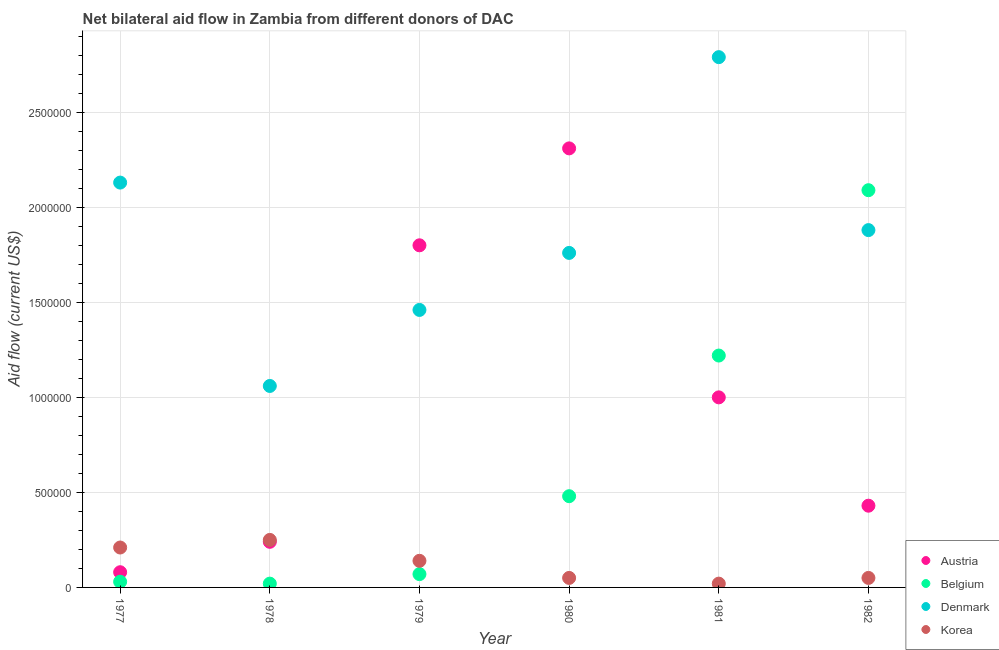Is the number of dotlines equal to the number of legend labels?
Your answer should be very brief. Yes. What is the amount of aid given by korea in 1978?
Give a very brief answer. 2.50e+05. Across all years, what is the maximum amount of aid given by belgium?
Provide a short and direct response. 2.09e+06. Across all years, what is the minimum amount of aid given by korea?
Give a very brief answer. 2.00e+04. In which year was the amount of aid given by austria maximum?
Your answer should be very brief. 1980. In which year was the amount of aid given by belgium minimum?
Provide a short and direct response. 1978. What is the total amount of aid given by belgium in the graph?
Offer a very short reply. 3.91e+06. What is the difference between the amount of aid given by denmark in 1978 and that in 1979?
Offer a very short reply. -4.00e+05. What is the difference between the amount of aid given by denmark in 1981 and the amount of aid given by austria in 1977?
Make the answer very short. 2.71e+06. What is the average amount of aid given by austria per year?
Your response must be concise. 9.77e+05. In the year 1978, what is the difference between the amount of aid given by austria and amount of aid given by belgium?
Your answer should be very brief. 2.20e+05. What is the ratio of the amount of aid given by denmark in 1977 to that in 1981?
Your answer should be very brief. 0.76. What is the difference between the highest and the second highest amount of aid given by austria?
Offer a terse response. 5.10e+05. What is the difference between the highest and the lowest amount of aid given by austria?
Keep it short and to the point. 2.23e+06. In how many years, is the amount of aid given by denmark greater than the average amount of aid given by denmark taken over all years?
Your response must be concise. 3. Is the sum of the amount of aid given by denmark in 1978 and 1981 greater than the maximum amount of aid given by korea across all years?
Offer a terse response. Yes. How many years are there in the graph?
Give a very brief answer. 6. What is the difference between two consecutive major ticks on the Y-axis?
Your answer should be compact. 5.00e+05. Does the graph contain any zero values?
Make the answer very short. No. Where does the legend appear in the graph?
Offer a terse response. Bottom right. How are the legend labels stacked?
Your answer should be compact. Vertical. What is the title of the graph?
Your answer should be very brief. Net bilateral aid flow in Zambia from different donors of DAC. What is the Aid flow (current US$) in Austria in 1977?
Provide a succinct answer. 8.00e+04. What is the Aid flow (current US$) in Belgium in 1977?
Keep it short and to the point. 3.00e+04. What is the Aid flow (current US$) of Denmark in 1977?
Your answer should be compact. 2.13e+06. What is the Aid flow (current US$) of Belgium in 1978?
Provide a short and direct response. 2.00e+04. What is the Aid flow (current US$) in Denmark in 1978?
Your answer should be very brief. 1.06e+06. What is the Aid flow (current US$) of Austria in 1979?
Offer a very short reply. 1.80e+06. What is the Aid flow (current US$) of Belgium in 1979?
Offer a terse response. 7.00e+04. What is the Aid flow (current US$) in Denmark in 1979?
Ensure brevity in your answer.  1.46e+06. What is the Aid flow (current US$) in Austria in 1980?
Keep it short and to the point. 2.31e+06. What is the Aid flow (current US$) of Belgium in 1980?
Offer a terse response. 4.80e+05. What is the Aid flow (current US$) of Denmark in 1980?
Keep it short and to the point. 1.76e+06. What is the Aid flow (current US$) in Korea in 1980?
Your response must be concise. 5.00e+04. What is the Aid flow (current US$) of Austria in 1981?
Provide a short and direct response. 1.00e+06. What is the Aid flow (current US$) of Belgium in 1981?
Your response must be concise. 1.22e+06. What is the Aid flow (current US$) of Denmark in 1981?
Keep it short and to the point. 2.79e+06. What is the Aid flow (current US$) of Korea in 1981?
Your response must be concise. 2.00e+04. What is the Aid flow (current US$) in Austria in 1982?
Keep it short and to the point. 4.30e+05. What is the Aid flow (current US$) in Belgium in 1982?
Your answer should be very brief. 2.09e+06. What is the Aid flow (current US$) in Denmark in 1982?
Your response must be concise. 1.88e+06. What is the Aid flow (current US$) in Korea in 1982?
Offer a very short reply. 5.00e+04. Across all years, what is the maximum Aid flow (current US$) of Austria?
Ensure brevity in your answer.  2.31e+06. Across all years, what is the maximum Aid flow (current US$) in Belgium?
Your response must be concise. 2.09e+06. Across all years, what is the maximum Aid flow (current US$) of Denmark?
Your answer should be compact. 2.79e+06. Across all years, what is the minimum Aid flow (current US$) in Austria?
Your answer should be very brief. 8.00e+04. Across all years, what is the minimum Aid flow (current US$) in Denmark?
Offer a terse response. 1.06e+06. What is the total Aid flow (current US$) in Austria in the graph?
Offer a very short reply. 5.86e+06. What is the total Aid flow (current US$) of Belgium in the graph?
Provide a short and direct response. 3.91e+06. What is the total Aid flow (current US$) in Denmark in the graph?
Keep it short and to the point. 1.11e+07. What is the total Aid flow (current US$) of Korea in the graph?
Provide a short and direct response. 7.20e+05. What is the difference between the Aid flow (current US$) of Belgium in 1977 and that in 1978?
Your answer should be compact. 10000. What is the difference between the Aid flow (current US$) in Denmark in 1977 and that in 1978?
Offer a very short reply. 1.07e+06. What is the difference between the Aid flow (current US$) in Korea in 1977 and that in 1978?
Give a very brief answer. -4.00e+04. What is the difference between the Aid flow (current US$) in Austria in 1977 and that in 1979?
Offer a very short reply. -1.72e+06. What is the difference between the Aid flow (current US$) in Belgium in 1977 and that in 1979?
Keep it short and to the point. -4.00e+04. What is the difference between the Aid flow (current US$) in Denmark in 1977 and that in 1979?
Provide a succinct answer. 6.70e+05. What is the difference between the Aid flow (current US$) in Austria in 1977 and that in 1980?
Offer a very short reply. -2.23e+06. What is the difference between the Aid flow (current US$) of Belgium in 1977 and that in 1980?
Provide a short and direct response. -4.50e+05. What is the difference between the Aid flow (current US$) in Austria in 1977 and that in 1981?
Your answer should be very brief. -9.20e+05. What is the difference between the Aid flow (current US$) of Belgium in 1977 and that in 1981?
Provide a succinct answer. -1.19e+06. What is the difference between the Aid flow (current US$) of Denmark in 1977 and that in 1981?
Provide a short and direct response. -6.60e+05. What is the difference between the Aid flow (current US$) in Austria in 1977 and that in 1982?
Keep it short and to the point. -3.50e+05. What is the difference between the Aid flow (current US$) of Belgium in 1977 and that in 1982?
Keep it short and to the point. -2.06e+06. What is the difference between the Aid flow (current US$) of Denmark in 1977 and that in 1982?
Offer a terse response. 2.50e+05. What is the difference between the Aid flow (current US$) of Korea in 1977 and that in 1982?
Provide a short and direct response. 1.60e+05. What is the difference between the Aid flow (current US$) of Austria in 1978 and that in 1979?
Keep it short and to the point. -1.56e+06. What is the difference between the Aid flow (current US$) in Belgium in 1978 and that in 1979?
Make the answer very short. -5.00e+04. What is the difference between the Aid flow (current US$) in Denmark in 1978 and that in 1979?
Your answer should be compact. -4.00e+05. What is the difference between the Aid flow (current US$) of Korea in 1978 and that in 1979?
Provide a short and direct response. 1.10e+05. What is the difference between the Aid flow (current US$) of Austria in 1978 and that in 1980?
Provide a succinct answer. -2.07e+06. What is the difference between the Aid flow (current US$) in Belgium in 1978 and that in 1980?
Your answer should be compact. -4.60e+05. What is the difference between the Aid flow (current US$) of Denmark in 1978 and that in 1980?
Give a very brief answer. -7.00e+05. What is the difference between the Aid flow (current US$) of Korea in 1978 and that in 1980?
Your response must be concise. 2.00e+05. What is the difference between the Aid flow (current US$) of Austria in 1978 and that in 1981?
Keep it short and to the point. -7.60e+05. What is the difference between the Aid flow (current US$) in Belgium in 1978 and that in 1981?
Ensure brevity in your answer.  -1.20e+06. What is the difference between the Aid flow (current US$) of Denmark in 1978 and that in 1981?
Give a very brief answer. -1.73e+06. What is the difference between the Aid flow (current US$) of Korea in 1978 and that in 1981?
Provide a short and direct response. 2.30e+05. What is the difference between the Aid flow (current US$) in Belgium in 1978 and that in 1982?
Your response must be concise. -2.07e+06. What is the difference between the Aid flow (current US$) in Denmark in 1978 and that in 1982?
Offer a terse response. -8.20e+05. What is the difference between the Aid flow (current US$) in Korea in 1978 and that in 1982?
Offer a terse response. 2.00e+05. What is the difference between the Aid flow (current US$) in Austria in 1979 and that in 1980?
Your answer should be very brief. -5.10e+05. What is the difference between the Aid flow (current US$) of Belgium in 1979 and that in 1980?
Offer a terse response. -4.10e+05. What is the difference between the Aid flow (current US$) of Austria in 1979 and that in 1981?
Your answer should be compact. 8.00e+05. What is the difference between the Aid flow (current US$) in Belgium in 1979 and that in 1981?
Give a very brief answer. -1.15e+06. What is the difference between the Aid flow (current US$) of Denmark in 1979 and that in 1981?
Offer a terse response. -1.33e+06. What is the difference between the Aid flow (current US$) in Austria in 1979 and that in 1982?
Make the answer very short. 1.37e+06. What is the difference between the Aid flow (current US$) in Belgium in 1979 and that in 1982?
Your answer should be very brief. -2.02e+06. What is the difference between the Aid flow (current US$) of Denmark in 1979 and that in 1982?
Your answer should be compact. -4.20e+05. What is the difference between the Aid flow (current US$) in Austria in 1980 and that in 1981?
Offer a terse response. 1.31e+06. What is the difference between the Aid flow (current US$) in Belgium in 1980 and that in 1981?
Provide a short and direct response. -7.40e+05. What is the difference between the Aid flow (current US$) of Denmark in 1980 and that in 1981?
Offer a terse response. -1.03e+06. What is the difference between the Aid flow (current US$) in Korea in 1980 and that in 1981?
Make the answer very short. 3.00e+04. What is the difference between the Aid flow (current US$) in Austria in 1980 and that in 1982?
Your answer should be compact. 1.88e+06. What is the difference between the Aid flow (current US$) of Belgium in 1980 and that in 1982?
Give a very brief answer. -1.61e+06. What is the difference between the Aid flow (current US$) in Korea in 1980 and that in 1982?
Offer a very short reply. 0. What is the difference between the Aid flow (current US$) in Austria in 1981 and that in 1982?
Provide a succinct answer. 5.70e+05. What is the difference between the Aid flow (current US$) in Belgium in 1981 and that in 1982?
Ensure brevity in your answer.  -8.70e+05. What is the difference between the Aid flow (current US$) in Denmark in 1981 and that in 1982?
Keep it short and to the point. 9.10e+05. What is the difference between the Aid flow (current US$) in Korea in 1981 and that in 1982?
Your response must be concise. -3.00e+04. What is the difference between the Aid flow (current US$) in Austria in 1977 and the Aid flow (current US$) in Denmark in 1978?
Offer a very short reply. -9.80e+05. What is the difference between the Aid flow (current US$) in Austria in 1977 and the Aid flow (current US$) in Korea in 1978?
Keep it short and to the point. -1.70e+05. What is the difference between the Aid flow (current US$) of Belgium in 1977 and the Aid flow (current US$) of Denmark in 1978?
Your response must be concise. -1.03e+06. What is the difference between the Aid flow (current US$) in Denmark in 1977 and the Aid flow (current US$) in Korea in 1978?
Make the answer very short. 1.88e+06. What is the difference between the Aid flow (current US$) in Austria in 1977 and the Aid flow (current US$) in Denmark in 1979?
Ensure brevity in your answer.  -1.38e+06. What is the difference between the Aid flow (current US$) of Austria in 1977 and the Aid flow (current US$) of Korea in 1979?
Ensure brevity in your answer.  -6.00e+04. What is the difference between the Aid flow (current US$) of Belgium in 1977 and the Aid flow (current US$) of Denmark in 1979?
Ensure brevity in your answer.  -1.43e+06. What is the difference between the Aid flow (current US$) in Denmark in 1977 and the Aid flow (current US$) in Korea in 1979?
Make the answer very short. 1.99e+06. What is the difference between the Aid flow (current US$) in Austria in 1977 and the Aid flow (current US$) in Belgium in 1980?
Your response must be concise. -4.00e+05. What is the difference between the Aid flow (current US$) of Austria in 1977 and the Aid flow (current US$) of Denmark in 1980?
Provide a short and direct response. -1.68e+06. What is the difference between the Aid flow (current US$) in Belgium in 1977 and the Aid flow (current US$) in Denmark in 1980?
Offer a very short reply. -1.73e+06. What is the difference between the Aid flow (current US$) of Denmark in 1977 and the Aid flow (current US$) of Korea in 1980?
Make the answer very short. 2.08e+06. What is the difference between the Aid flow (current US$) of Austria in 1977 and the Aid flow (current US$) of Belgium in 1981?
Offer a terse response. -1.14e+06. What is the difference between the Aid flow (current US$) in Austria in 1977 and the Aid flow (current US$) in Denmark in 1981?
Your answer should be very brief. -2.71e+06. What is the difference between the Aid flow (current US$) in Austria in 1977 and the Aid flow (current US$) in Korea in 1981?
Give a very brief answer. 6.00e+04. What is the difference between the Aid flow (current US$) in Belgium in 1977 and the Aid flow (current US$) in Denmark in 1981?
Offer a terse response. -2.76e+06. What is the difference between the Aid flow (current US$) in Denmark in 1977 and the Aid flow (current US$) in Korea in 1981?
Provide a succinct answer. 2.11e+06. What is the difference between the Aid flow (current US$) of Austria in 1977 and the Aid flow (current US$) of Belgium in 1982?
Your answer should be very brief. -2.01e+06. What is the difference between the Aid flow (current US$) of Austria in 1977 and the Aid flow (current US$) of Denmark in 1982?
Your answer should be compact. -1.80e+06. What is the difference between the Aid flow (current US$) in Austria in 1977 and the Aid flow (current US$) in Korea in 1982?
Offer a terse response. 3.00e+04. What is the difference between the Aid flow (current US$) in Belgium in 1977 and the Aid flow (current US$) in Denmark in 1982?
Provide a short and direct response. -1.85e+06. What is the difference between the Aid flow (current US$) of Belgium in 1977 and the Aid flow (current US$) of Korea in 1982?
Your answer should be very brief. -2.00e+04. What is the difference between the Aid flow (current US$) of Denmark in 1977 and the Aid flow (current US$) of Korea in 1982?
Make the answer very short. 2.08e+06. What is the difference between the Aid flow (current US$) of Austria in 1978 and the Aid flow (current US$) of Denmark in 1979?
Ensure brevity in your answer.  -1.22e+06. What is the difference between the Aid flow (current US$) of Belgium in 1978 and the Aid flow (current US$) of Denmark in 1979?
Your answer should be compact. -1.44e+06. What is the difference between the Aid flow (current US$) in Denmark in 1978 and the Aid flow (current US$) in Korea in 1979?
Make the answer very short. 9.20e+05. What is the difference between the Aid flow (current US$) of Austria in 1978 and the Aid flow (current US$) of Denmark in 1980?
Offer a very short reply. -1.52e+06. What is the difference between the Aid flow (current US$) in Austria in 1978 and the Aid flow (current US$) in Korea in 1980?
Your answer should be compact. 1.90e+05. What is the difference between the Aid flow (current US$) of Belgium in 1978 and the Aid flow (current US$) of Denmark in 1980?
Ensure brevity in your answer.  -1.74e+06. What is the difference between the Aid flow (current US$) in Denmark in 1978 and the Aid flow (current US$) in Korea in 1980?
Give a very brief answer. 1.01e+06. What is the difference between the Aid flow (current US$) in Austria in 1978 and the Aid flow (current US$) in Belgium in 1981?
Offer a very short reply. -9.80e+05. What is the difference between the Aid flow (current US$) in Austria in 1978 and the Aid flow (current US$) in Denmark in 1981?
Offer a very short reply. -2.55e+06. What is the difference between the Aid flow (current US$) of Belgium in 1978 and the Aid flow (current US$) of Denmark in 1981?
Your answer should be very brief. -2.77e+06. What is the difference between the Aid flow (current US$) in Belgium in 1978 and the Aid flow (current US$) in Korea in 1981?
Make the answer very short. 0. What is the difference between the Aid flow (current US$) of Denmark in 1978 and the Aid flow (current US$) of Korea in 1981?
Offer a very short reply. 1.04e+06. What is the difference between the Aid flow (current US$) in Austria in 1978 and the Aid flow (current US$) in Belgium in 1982?
Provide a short and direct response. -1.85e+06. What is the difference between the Aid flow (current US$) of Austria in 1978 and the Aid flow (current US$) of Denmark in 1982?
Offer a terse response. -1.64e+06. What is the difference between the Aid flow (current US$) in Austria in 1978 and the Aid flow (current US$) in Korea in 1982?
Keep it short and to the point. 1.90e+05. What is the difference between the Aid flow (current US$) of Belgium in 1978 and the Aid flow (current US$) of Denmark in 1982?
Provide a short and direct response. -1.86e+06. What is the difference between the Aid flow (current US$) in Belgium in 1978 and the Aid flow (current US$) in Korea in 1982?
Offer a terse response. -3.00e+04. What is the difference between the Aid flow (current US$) in Denmark in 1978 and the Aid flow (current US$) in Korea in 1982?
Keep it short and to the point. 1.01e+06. What is the difference between the Aid flow (current US$) of Austria in 1979 and the Aid flow (current US$) of Belgium in 1980?
Your answer should be very brief. 1.32e+06. What is the difference between the Aid flow (current US$) of Austria in 1979 and the Aid flow (current US$) of Denmark in 1980?
Your response must be concise. 4.00e+04. What is the difference between the Aid flow (current US$) of Austria in 1979 and the Aid flow (current US$) of Korea in 1980?
Provide a succinct answer. 1.75e+06. What is the difference between the Aid flow (current US$) in Belgium in 1979 and the Aid flow (current US$) in Denmark in 1980?
Provide a succinct answer. -1.69e+06. What is the difference between the Aid flow (current US$) in Belgium in 1979 and the Aid flow (current US$) in Korea in 1980?
Your answer should be compact. 2.00e+04. What is the difference between the Aid flow (current US$) in Denmark in 1979 and the Aid flow (current US$) in Korea in 1980?
Make the answer very short. 1.41e+06. What is the difference between the Aid flow (current US$) of Austria in 1979 and the Aid flow (current US$) of Belgium in 1981?
Provide a short and direct response. 5.80e+05. What is the difference between the Aid flow (current US$) in Austria in 1979 and the Aid flow (current US$) in Denmark in 1981?
Make the answer very short. -9.90e+05. What is the difference between the Aid flow (current US$) in Austria in 1979 and the Aid flow (current US$) in Korea in 1981?
Ensure brevity in your answer.  1.78e+06. What is the difference between the Aid flow (current US$) in Belgium in 1979 and the Aid flow (current US$) in Denmark in 1981?
Make the answer very short. -2.72e+06. What is the difference between the Aid flow (current US$) in Belgium in 1979 and the Aid flow (current US$) in Korea in 1981?
Your answer should be very brief. 5.00e+04. What is the difference between the Aid flow (current US$) of Denmark in 1979 and the Aid flow (current US$) of Korea in 1981?
Your answer should be very brief. 1.44e+06. What is the difference between the Aid flow (current US$) of Austria in 1979 and the Aid flow (current US$) of Korea in 1982?
Make the answer very short. 1.75e+06. What is the difference between the Aid flow (current US$) in Belgium in 1979 and the Aid flow (current US$) in Denmark in 1982?
Provide a short and direct response. -1.81e+06. What is the difference between the Aid flow (current US$) of Denmark in 1979 and the Aid flow (current US$) of Korea in 1982?
Make the answer very short. 1.41e+06. What is the difference between the Aid flow (current US$) of Austria in 1980 and the Aid flow (current US$) of Belgium in 1981?
Provide a short and direct response. 1.09e+06. What is the difference between the Aid flow (current US$) in Austria in 1980 and the Aid flow (current US$) in Denmark in 1981?
Give a very brief answer. -4.80e+05. What is the difference between the Aid flow (current US$) of Austria in 1980 and the Aid flow (current US$) of Korea in 1981?
Provide a succinct answer. 2.29e+06. What is the difference between the Aid flow (current US$) in Belgium in 1980 and the Aid flow (current US$) in Denmark in 1981?
Provide a succinct answer. -2.31e+06. What is the difference between the Aid flow (current US$) of Belgium in 1980 and the Aid flow (current US$) of Korea in 1981?
Make the answer very short. 4.60e+05. What is the difference between the Aid flow (current US$) in Denmark in 1980 and the Aid flow (current US$) in Korea in 1981?
Provide a short and direct response. 1.74e+06. What is the difference between the Aid flow (current US$) in Austria in 1980 and the Aid flow (current US$) in Belgium in 1982?
Your answer should be compact. 2.20e+05. What is the difference between the Aid flow (current US$) of Austria in 1980 and the Aid flow (current US$) of Korea in 1982?
Provide a short and direct response. 2.26e+06. What is the difference between the Aid flow (current US$) of Belgium in 1980 and the Aid flow (current US$) of Denmark in 1982?
Your response must be concise. -1.40e+06. What is the difference between the Aid flow (current US$) of Belgium in 1980 and the Aid flow (current US$) of Korea in 1982?
Your answer should be compact. 4.30e+05. What is the difference between the Aid flow (current US$) of Denmark in 1980 and the Aid flow (current US$) of Korea in 1982?
Offer a very short reply. 1.71e+06. What is the difference between the Aid flow (current US$) in Austria in 1981 and the Aid flow (current US$) in Belgium in 1982?
Give a very brief answer. -1.09e+06. What is the difference between the Aid flow (current US$) in Austria in 1981 and the Aid flow (current US$) in Denmark in 1982?
Provide a succinct answer. -8.80e+05. What is the difference between the Aid flow (current US$) in Austria in 1981 and the Aid flow (current US$) in Korea in 1982?
Your response must be concise. 9.50e+05. What is the difference between the Aid flow (current US$) in Belgium in 1981 and the Aid flow (current US$) in Denmark in 1982?
Your answer should be very brief. -6.60e+05. What is the difference between the Aid flow (current US$) in Belgium in 1981 and the Aid flow (current US$) in Korea in 1982?
Make the answer very short. 1.17e+06. What is the difference between the Aid flow (current US$) of Denmark in 1981 and the Aid flow (current US$) of Korea in 1982?
Keep it short and to the point. 2.74e+06. What is the average Aid flow (current US$) of Austria per year?
Give a very brief answer. 9.77e+05. What is the average Aid flow (current US$) of Belgium per year?
Keep it short and to the point. 6.52e+05. What is the average Aid flow (current US$) of Denmark per year?
Your response must be concise. 1.85e+06. In the year 1977, what is the difference between the Aid flow (current US$) of Austria and Aid flow (current US$) of Belgium?
Give a very brief answer. 5.00e+04. In the year 1977, what is the difference between the Aid flow (current US$) of Austria and Aid flow (current US$) of Denmark?
Keep it short and to the point. -2.05e+06. In the year 1977, what is the difference between the Aid flow (current US$) of Belgium and Aid flow (current US$) of Denmark?
Your answer should be very brief. -2.10e+06. In the year 1977, what is the difference between the Aid flow (current US$) of Belgium and Aid flow (current US$) of Korea?
Make the answer very short. -1.80e+05. In the year 1977, what is the difference between the Aid flow (current US$) of Denmark and Aid flow (current US$) of Korea?
Your answer should be very brief. 1.92e+06. In the year 1978, what is the difference between the Aid flow (current US$) in Austria and Aid flow (current US$) in Belgium?
Provide a succinct answer. 2.20e+05. In the year 1978, what is the difference between the Aid flow (current US$) in Austria and Aid flow (current US$) in Denmark?
Your answer should be very brief. -8.20e+05. In the year 1978, what is the difference between the Aid flow (current US$) of Austria and Aid flow (current US$) of Korea?
Offer a terse response. -10000. In the year 1978, what is the difference between the Aid flow (current US$) in Belgium and Aid flow (current US$) in Denmark?
Keep it short and to the point. -1.04e+06. In the year 1978, what is the difference between the Aid flow (current US$) in Belgium and Aid flow (current US$) in Korea?
Ensure brevity in your answer.  -2.30e+05. In the year 1978, what is the difference between the Aid flow (current US$) in Denmark and Aid flow (current US$) in Korea?
Your answer should be compact. 8.10e+05. In the year 1979, what is the difference between the Aid flow (current US$) in Austria and Aid flow (current US$) in Belgium?
Provide a short and direct response. 1.73e+06. In the year 1979, what is the difference between the Aid flow (current US$) of Austria and Aid flow (current US$) of Denmark?
Your answer should be very brief. 3.40e+05. In the year 1979, what is the difference between the Aid flow (current US$) in Austria and Aid flow (current US$) in Korea?
Your answer should be very brief. 1.66e+06. In the year 1979, what is the difference between the Aid flow (current US$) in Belgium and Aid flow (current US$) in Denmark?
Offer a very short reply. -1.39e+06. In the year 1979, what is the difference between the Aid flow (current US$) in Belgium and Aid flow (current US$) in Korea?
Make the answer very short. -7.00e+04. In the year 1979, what is the difference between the Aid flow (current US$) of Denmark and Aid flow (current US$) of Korea?
Provide a succinct answer. 1.32e+06. In the year 1980, what is the difference between the Aid flow (current US$) of Austria and Aid flow (current US$) of Belgium?
Ensure brevity in your answer.  1.83e+06. In the year 1980, what is the difference between the Aid flow (current US$) in Austria and Aid flow (current US$) in Denmark?
Offer a very short reply. 5.50e+05. In the year 1980, what is the difference between the Aid flow (current US$) in Austria and Aid flow (current US$) in Korea?
Your answer should be compact. 2.26e+06. In the year 1980, what is the difference between the Aid flow (current US$) in Belgium and Aid flow (current US$) in Denmark?
Ensure brevity in your answer.  -1.28e+06. In the year 1980, what is the difference between the Aid flow (current US$) in Belgium and Aid flow (current US$) in Korea?
Your answer should be compact. 4.30e+05. In the year 1980, what is the difference between the Aid flow (current US$) in Denmark and Aid flow (current US$) in Korea?
Provide a succinct answer. 1.71e+06. In the year 1981, what is the difference between the Aid flow (current US$) of Austria and Aid flow (current US$) of Denmark?
Your answer should be compact. -1.79e+06. In the year 1981, what is the difference between the Aid flow (current US$) in Austria and Aid flow (current US$) in Korea?
Ensure brevity in your answer.  9.80e+05. In the year 1981, what is the difference between the Aid flow (current US$) of Belgium and Aid flow (current US$) of Denmark?
Provide a short and direct response. -1.57e+06. In the year 1981, what is the difference between the Aid flow (current US$) in Belgium and Aid flow (current US$) in Korea?
Give a very brief answer. 1.20e+06. In the year 1981, what is the difference between the Aid flow (current US$) in Denmark and Aid flow (current US$) in Korea?
Offer a very short reply. 2.77e+06. In the year 1982, what is the difference between the Aid flow (current US$) of Austria and Aid flow (current US$) of Belgium?
Ensure brevity in your answer.  -1.66e+06. In the year 1982, what is the difference between the Aid flow (current US$) in Austria and Aid flow (current US$) in Denmark?
Offer a very short reply. -1.45e+06. In the year 1982, what is the difference between the Aid flow (current US$) in Belgium and Aid flow (current US$) in Denmark?
Make the answer very short. 2.10e+05. In the year 1982, what is the difference between the Aid flow (current US$) of Belgium and Aid flow (current US$) of Korea?
Provide a succinct answer. 2.04e+06. In the year 1982, what is the difference between the Aid flow (current US$) in Denmark and Aid flow (current US$) in Korea?
Provide a succinct answer. 1.83e+06. What is the ratio of the Aid flow (current US$) of Austria in 1977 to that in 1978?
Your response must be concise. 0.33. What is the ratio of the Aid flow (current US$) of Belgium in 1977 to that in 1978?
Provide a succinct answer. 1.5. What is the ratio of the Aid flow (current US$) of Denmark in 1977 to that in 1978?
Make the answer very short. 2.01. What is the ratio of the Aid flow (current US$) in Korea in 1977 to that in 1978?
Provide a succinct answer. 0.84. What is the ratio of the Aid flow (current US$) of Austria in 1977 to that in 1979?
Make the answer very short. 0.04. What is the ratio of the Aid flow (current US$) in Belgium in 1977 to that in 1979?
Offer a terse response. 0.43. What is the ratio of the Aid flow (current US$) in Denmark in 1977 to that in 1979?
Provide a succinct answer. 1.46. What is the ratio of the Aid flow (current US$) in Korea in 1977 to that in 1979?
Your answer should be compact. 1.5. What is the ratio of the Aid flow (current US$) in Austria in 1977 to that in 1980?
Give a very brief answer. 0.03. What is the ratio of the Aid flow (current US$) of Belgium in 1977 to that in 1980?
Keep it short and to the point. 0.06. What is the ratio of the Aid flow (current US$) of Denmark in 1977 to that in 1980?
Your response must be concise. 1.21. What is the ratio of the Aid flow (current US$) of Korea in 1977 to that in 1980?
Make the answer very short. 4.2. What is the ratio of the Aid flow (current US$) in Belgium in 1977 to that in 1981?
Provide a short and direct response. 0.02. What is the ratio of the Aid flow (current US$) in Denmark in 1977 to that in 1981?
Ensure brevity in your answer.  0.76. What is the ratio of the Aid flow (current US$) in Korea in 1977 to that in 1981?
Offer a very short reply. 10.5. What is the ratio of the Aid flow (current US$) of Austria in 1977 to that in 1982?
Your answer should be compact. 0.19. What is the ratio of the Aid flow (current US$) of Belgium in 1977 to that in 1982?
Ensure brevity in your answer.  0.01. What is the ratio of the Aid flow (current US$) in Denmark in 1977 to that in 1982?
Your response must be concise. 1.13. What is the ratio of the Aid flow (current US$) of Austria in 1978 to that in 1979?
Provide a short and direct response. 0.13. What is the ratio of the Aid flow (current US$) of Belgium in 1978 to that in 1979?
Offer a terse response. 0.29. What is the ratio of the Aid flow (current US$) in Denmark in 1978 to that in 1979?
Keep it short and to the point. 0.73. What is the ratio of the Aid flow (current US$) of Korea in 1978 to that in 1979?
Provide a succinct answer. 1.79. What is the ratio of the Aid flow (current US$) in Austria in 1978 to that in 1980?
Make the answer very short. 0.1. What is the ratio of the Aid flow (current US$) of Belgium in 1978 to that in 1980?
Your response must be concise. 0.04. What is the ratio of the Aid flow (current US$) in Denmark in 1978 to that in 1980?
Provide a short and direct response. 0.6. What is the ratio of the Aid flow (current US$) of Austria in 1978 to that in 1981?
Provide a short and direct response. 0.24. What is the ratio of the Aid flow (current US$) in Belgium in 1978 to that in 1981?
Give a very brief answer. 0.02. What is the ratio of the Aid flow (current US$) of Denmark in 1978 to that in 1981?
Keep it short and to the point. 0.38. What is the ratio of the Aid flow (current US$) in Korea in 1978 to that in 1981?
Keep it short and to the point. 12.5. What is the ratio of the Aid flow (current US$) in Austria in 1978 to that in 1982?
Offer a very short reply. 0.56. What is the ratio of the Aid flow (current US$) in Belgium in 1978 to that in 1982?
Make the answer very short. 0.01. What is the ratio of the Aid flow (current US$) of Denmark in 1978 to that in 1982?
Offer a very short reply. 0.56. What is the ratio of the Aid flow (current US$) of Austria in 1979 to that in 1980?
Ensure brevity in your answer.  0.78. What is the ratio of the Aid flow (current US$) of Belgium in 1979 to that in 1980?
Give a very brief answer. 0.15. What is the ratio of the Aid flow (current US$) in Denmark in 1979 to that in 1980?
Make the answer very short. 0.83. What is the ratio of the Aid flow (current US$) of Austria in 1979 to that in 1981?
Offer a terse response. 1.8. What is the ratio of the Aid flow (current US$) in Belgium in 1979 to that in 1981?
Give a very brief answer. 0.06. What is the ratio of the Aid flow (current US$) of Denmark in 1979 to that in 1981?
Give a very brief answer. 0.52. What is the ratio of the Aid flow (current US$) in Korea in 1979 to that in 1981?
Make the answer very short. 7. What is the ratio of the Aid flow (current US$) in Austria in 1979 to that in 1982?
Give a very brief answer. 4.19. What is the ratio of the Aid flow (current US$) of Belgium in 1979 to that in 1982?
Offer a terse response. 0.03. What is the ratio of the Aid flow (current US$) in Denmark in 1979 to that in 1982?
Offer a terse response. 0.78. What is the ratio of the Aid flow (current US$) of Korea in 1979 to that in 1982?
Provide a succinct answer. 2.8. What is the ratio of the Aid flow (current US$) of Austria in 1980 to that in 1981?
Provide a succinct answer. 2.31. What is the ratio of the Aid flow (current US$) of Belgium in 1980 to that in 1981?
Your response must be concise. 0.39. What is the ratio of the Aid flow (current US$) in Denmark in 1980 to that in 1981?
Offer a terse response. 0.63. What is the ratio of the Aid flow (current US$) in Austria in 1980 to that in 1982?
Ensure brevity in your answer.  5.37. What is the ratio of the Aid flow (current US$) of Belgium in 1980 to that in 1982?
Provide a short and direct response. 0.23. What is the ratio of the Aid flow (current US$) in Denmark in 1980 to that in 1982?
Give a very brief answer. 0.94. What is the ratio of the Aid flow (current US$) in Austria in 1981 to that in 1982?
Keep it short and to the point. 2.33. What is the ratio of the Aid flow (current US$) in Belgium in 1981 to that in 1982?
Give a very brief answer. 0.58. What is the ratio of the Aid flow (current US$) in Denmark in 1981 to that in 1982?
Give a very brief answer. 1.48. What is the ratio of the Aid flow (current US$) in Korea in 1981 to that in 1982?
Give a very brief answer. 0.4. What is the difference between the highest and the second highest Aid flow (current US$) of Austria?
Give a very brief answer. 5.10e+05. What is the difference between the highest and the second highest Aid flow (current US$) in Belgium?
Ensure brevity in your answer.  8.70e+05. What is the difference between the highest and the second highest Aid flow (current US$) of Korea?
Your answer should be compact. 4.00e+04. What is the difference between the highest and the lowest Aid flow (current US$) in Austria?
Your answer should be very brief. 2.23e+06. What is the difference between the highest and the lowest Aid flow (current US$) in Belgium?
Keep it short and to the point. 2.07e+06. What is the difference between the highest and the lowest Aid flow (current US$) in Denmark?
Offer a terse response. 1.73e+06. What is the difference between the highest and the lowest Aid flow (current US$) in Korea?
Give a very brief answer. 2.30e+05. 